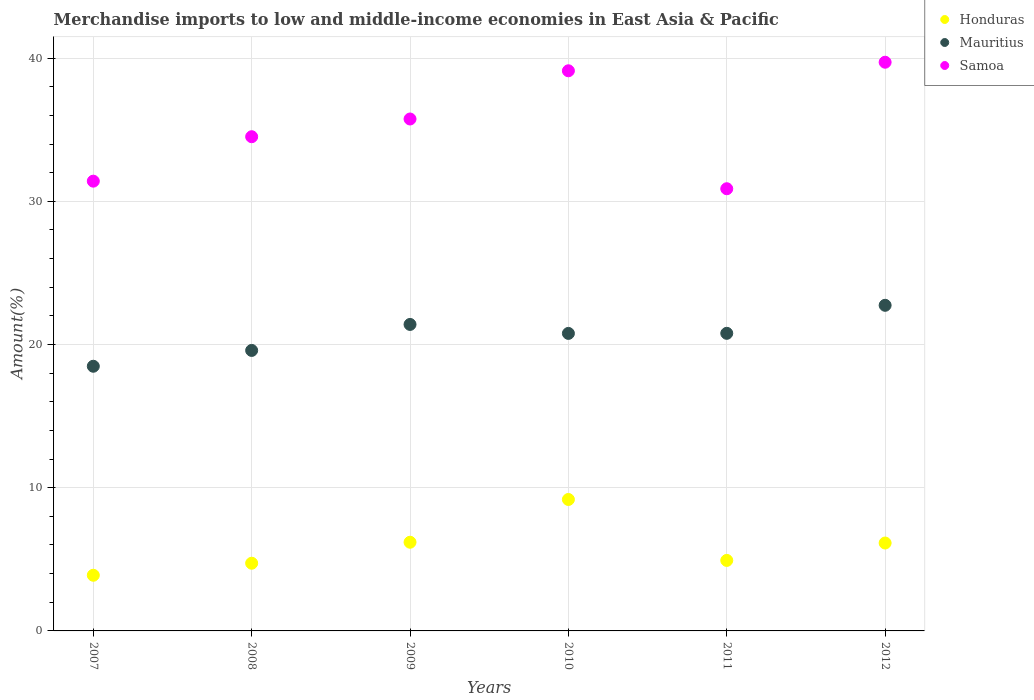How many different coloured dotlines are there?
Your answer should be very brief. 3. Is the number of dotlines equal to the number of legend labels?
Your answer should be very brief. Yes. What is the percentage of amount earned from merchandise imports in Samoa in 2008?
Keep it short and to the point. 34.51. Across all years, what is the maximum percentage of amount earned from merchandise imports in Mauritius?
Offer a terse response. 22.74. Across all years, what is the minimum percentage of amount earned from merchandise imports in Honduras?
Provide a succinct answer. 3.89. In which year was the percentage of amount earned from merchandise imports in Mauritius maximum?
Provide a short and direct response. 2012. In which year was the percentage of amount earned from merchandise imports in Samoa minimum?
Ensure brevity in your answer.  2011. What is the total percentage of amount earned from merchandise imports in Honduras in the graph?
Your response must be concise. 35.05. What is the difference between the percentage of amount earned from merchandise imports in Honduras in 2010 and that in 2012?
Give a very brief answer. 3.04. What is the difference between the percentage of amount earned from merchandise imports in Honduras in 2012 and the percentage of amount earned from merchandise imports in Mauritius in 2009?
Keep it short and to the point. -15.26. What is the average percentage of amount earned from merchandise imports in Honduras per year?
Your answer should be very brief. 5.84. In the year 2012, what is the difference between the percentage of amount earned from merchandise imports in Mauritius and percentage of amount earned from merchandise imports in Honduras?
Offer a terse response. 16.6. In how many years, is the percentage of amount earned from merchandise imports in Honduras greater than 14 %?
Offer a terse response. 0. What is the ratio of the percentage of amount earned from merchandise imports in Honduras in 2007 to that in 2010?
Your answer should be very brief. 0.42. What is the difference between the highest and the second highest percentage of amount earned from merchandise imports in Mauritius?
Offer a terse response. 1.34. What is the difference between the highest and the lowest percentage of amount earned from merchandise imports in Samoa?
Make the answer very short. 8.83. Is the sum of the percentage of amount earned from merchandise imports in Mauritius in 2007 and 2008 greater than the maximum percentage of amount earned from merchandise imports in Samoa across all years?
Keep it short and to the point. No. Is it the case that in every year, the sum of the percentage of amount earned from merchandise imports in Honduras and percentage of amount earned from merchandise imports in Samoa  is greater than the percentage of amount earned from merchandise imports in Mauritius?
Make the answer very short. Yes. Is the percentage of amount earned from merchandise imports in Samoa strictly greater than the percentage of amount earned from merchandise imports in Honduras over the years?
Offer a very short reply. Yes. Are the values on the major ticks of Y-axis written in scientific E-notation?
Keep it short and to the point. No. Does the graph contain any zero values?
Offer a terse response. No. Where does the legend appear in the graph?
Give a very brief answer. Top right. What is the title of the graph?
Ensure brevity in your answer.  Merchandise imports to low and middle-income economies in East Asia & Pacific. Does "Isle of Man" appear as one of the legend labels in the graph?
Offer a terse response. No. What is the label or title of the X-axis?
Make the answer very short. Years. What is the label or title of the Y-axis?
Offer a very short reply. Amount(%). What is the Amount(%) in Honduras in 2007?
Offer a terse response. 3.89. What is the Amount(%) of Mauritius in 2007?
Your answer should be very brief. 18.48. What is the Amount(%) in Samoa in 2007?
Ensure brevity in your answer.  31.41. What is the Amount(%) in Honduras in 2008?
Make the answer very short. 4.73. What is the Amount(%) in Mauritius in 2008?
Keep it short and to the point. 19.59. What is the Amount(%) of Samoa in 2008?
Your response must be concise. 34.51. What is the Amount(%) in Honduras in 2009?
Your response must be concise. 6.19. What is the Amount(%) of Mauritius in 2009?
Offer a very short reply. 21.4. What is the Amount(%) of Samoa in 2009?
Offer a very short reply. 35.75. What is the Amount(%) in Honduras in 2010?
Ensure brevity in your answer.  9.18. What is the Amount(%) in Mauritius in 2010?
Your response must be concise. 20.78. What is the Amount(%) in Samoa in 2010?
Your response must be concise. 39.11. What is the Amount(%) of Honduras in 2011?
Your answer should be compact. 4.92. What is the Amount(%) of Mauritius in 2011?
Keep it short and to the point. 20.78. What is the Amount(%) of Samoa in 2011?
Offer a very short reply. 30.88. What is the Amount(%) of Honduras in 2012?
Offer a terse response. 6.14. What is the Amount(%) in Mauritius in 2012?
Make the answer very short. 22.74. What is the Amount(%) of Samoa in 2012?
Your answer should be compact. 39.71. Across all years, what is the maximum Amount(%) in Honduras?
Offer a terse response. 9.18. Across all years, what is the maximum Amount(%) in Mauritius?
Keep it short and to the point. 22.74. Across all years, what is the maximum Amount(%) in Samoa?
Your response must be concise. 39.71. Across all years, what is the minimum Amount(%) of Honduras?
Your answer should be compact. 3.89. Across all years, what is the minimum Amount(%) in Mauritius?
Provide a succinct answer. 18.48. Across all years, what is the minimum Amount(%) in Samoa?
Your response must be concise. 30.88. What is the total Amount(%) in Honduras in the graph?
Offer a very short reply. 35.05. What is the total Amount(%) in Mauritius in the graph?
Your answer should be compact. 123.77. What is the total Amount(%) in Samoa in the graph?
Make the answer very short. 211.37. What is the difference between the Amount(%) of Honduras in 2007 and that in 2008?
Offer a terse response. -0.84. What is the difference between the Amount(%) of Mauritius in 2007 and that in 2008?
Provide a succinct answer. -1.1. What is the difference between the Amount(%) of Samoa in 2007 and that in 2008?
Make the answer very short. -3.1. What is the difference between the Amount(%) in Honduras in 2007 and that in 2009?
Your answer should be compact. -2.31. What is the difference between the Amount(%) in Mauritius in 2007 and that in 2009?
Provide a succinct answer. -2.92. What is the difference between the Amount(%) in Samoa in 2007 and that in 2009?
Make the answer very short. -4.34. What is the difference between the Amount(%) of Honduras in 2007 and that in 2010?
Provide a short and direct response. -5.29. What is the difference between the Amount(%) of Mauritius in 2007 and that in 2010?
Keep it short and to the point. -2.29. What is the difference between the Amount(%) of Samoa in 2007 and that in 2010?
Provide a short and direct response. -7.71. What is the difference between the Amount(%) in Honduras in 2007 and that in 2011?
Offer a terse response. -1.04. What is the difference between the Amount(%) of Mauritius in 2007 and that in 2011?
Give a very brief answer. -2.3. What is the difference between the Amount(%) in Samoa in 2007 and that in 2011?
Provide a succinct answer. 0.53. What is the difference between the Amount(%) in Honduras in 2007 and that in 2012?
Ensure brevity in your answer.  -2.25. What is the difference between the Amount(%) of Mauritius in 2007 and that in 2012?
Provide a succinct answer. -4.26. What is the difference between the Amount(%) in Samoa in 2007 and that in 2012?
Provide a succinct answer. -8.31. What is the difference between the Amount(%) in Honduras in 2008 and that in 2009?
Your answer should be compact. -1.47. What is the difference between the Amount(%) of Mauritius in 2008 and that in 2009?
Your answer should be very brief. -1.82. What is the difference between the Amount(%) of Samoa in 2008 and that in 2009?
Offer a terse response. -1.24. What is the difference between the Amount(%) of Honduras in 2008 and that in 2010?
Your answer should be very brief. -4.45. What is the difference between the Amount(%) of Mauritius in 2008 and that in 2010?
Your answer should be very brief. -1.19. What is the difference between the Amount(%) in Samoa in 2008 and that in 2010?
Your answer should be very brief. -4.6. What is the difference between the Amount(%) of Honduras in 2008 and that in 2011?
Your answer should be very brief. -0.2. What is the difference between the Amount(%) of Mauritius in 2008 and that in 2011?
Make the answer very short. -1.2. What is the difference between the Amount(%) of Samoa in 2008 and that in 2011?
Your response must be concise. 3.63. What is the difference between the Amount(%) of Honduras in 2008 and that in 2012?
Your answer should be very brief. -1.41. What is the difference between the Amount(%) of Mauritius in 2008 and that in 2012?
Your answer should be very brief. -3.15. What is the difference between the Amount(%) of Samoa in 2008 and that in 2012?
Provide a short and direct response. -5.2. What is the difference between the Amount(%) of Honduras in 2009 and that in 2010?
Give a very brief answer. -2.99. What is the difference between the Amount(%) in Mauritius in 2009 and that in 2010?
Provide a succinct answer. 0.63. What is the difference between the Amount(%) in Samoa in 2009 and that in 2010?
Provide a short and direct response. -3.37. What is the difference between the Amount(%) of Honduras in 2009 and that in 2011?
Make the answer very short. 1.27. What is the difference between the Amount(%) in Mauritius in 2009 and that in 2011?
Your response must be concise. 0.62. What is the difference between the Amount(%) in Samoa in 2009 and that in 2011?
Ensure brevity in your answer.  4.87. What is the difference between the Amount(%) of Honduras in 2009 and that in 2012?
Provide a succinct answer. 0.05. What is the difference between the Amount(%) of Mauritius in 2009 and that in 2012?
Your answer should be very brief. -1.34. What is the difference between the Amount(%) in Samoa in 2009 and that in 2012?
Keep it short and to the point. -3.96. What is the difference between the Amount(%) of Honduras in 2010 and that in 2011?
Keep it short and to the point. 4.26. What is the difference between the Amount(%) of Mauritius in 2010 and that in 2011?
Your answer should be compact. -0.01. What is the difference between the Amount(%) of Samoa in 2010 and that in 2011?
Offer a very short reply. 8.24. What is the difference between the Amount(%) of Honduras in 2010 and that in 2012?
Provide a short and direct response. 3.04. What is the difference between the Amount(%) of Mauritius in 2010 and that in 2012?
Offer a terse response. -1.96. What is the difference between the Amount(%) in Samoa in 2010 and that in 2012?
Offer a very short reply. -0.6. What is the difference between the Amount(%) of Honduras in 2011 and that in 2012?
Offer a very short reply. -1.21. What is the difference between the Amount(%) of Mauritius in 2011 and that in 2012?
Offer a terse response. -1.96. What is the difference between the Amount(%) of Samoa in 2011 and that in 2012?
Make the answer very short. -8.83. What is the difference between the Amount(%) in Honduras in 2007 and the Amount(%) in Mauritius in 2008?
Your response must be concise. -15.7. What is the difference between the Amount(%) in Honduras in 2007 and the Amount(%) in Samoa in 2008?
Offer a very short reply. -30.62. What is the difference between the Amount(%) in Mauritius in 2007 and the Amount(%) in Samoa in 2008?
Your answer should be very brief. -16.03. What is the difference between the Amount(%) in Honduras in 2007 and the Amount(%) in Mauritius in 2009?
Ensure brevity in your answer.  -17.52. What is the difference between the Amount(%) in Honduras in 2007 and the Amount(%) in Samoa in 2009?
Keep it short and to the point. -31.86. What is the difference between the Amount(%) of Mauritius in 2007 and the Amount(%) of Samoa in 2009?
Your answer should be compact. -17.27. What is the difference between the Amount(%) in Honduras in 2007 and the Amount(%) in Mauritius in 2010?
Offer a terse response. -16.89. What is the difference between the Amount(%) of Honduras in 2007 and the Amount(%) of Samoa in 2010?
Your response must be concise. -35.23. What is the difference between the Amount(%) of Mauritius in 2007 and the Amount(%) of Samoa in 2010?
Make the answer very short. -20.63. What is the difference between the Amount(%) in Honduras in 2007 and the Amount(%) in Mauritius in 2011?
Provide a succinct answer. -16.89. What is the difference between the Amount(%) of Honduras in 2007 and the Amount(%) of Samoa in 2011?
Provide a succinct answer. -26.99. What is the difference between the Amount(%) in Mauritius in 2007 and the Amount(%) in Samoa in 2011?
Ensure brevity in your answer.  -12.4. What is the difference between the Amount(%) of Honduras in 2007 and the Amount(%) of Mauritius in 2012?
Your response must be concise. -18.85. What is the difference between the Amount(%) in Honduras in 2007 and the Amount(%) in Samoa in 2012?
Your answer should be compact. -35.83. What is the difference between the Amount(%) in Mauritius in 2007 and the Amount(%) in Samoa in 2012?
Your answer should be compact. -21.23. What is the difference between the Amount(%) in Honduras in 2008 and the Amount(%) in Mauritius in 2009?
Provide a succinct answer. -16.67. What is the difference between the Amount(%) of Honduras in 2008 and the Amount(%) of Samoa in 2009?
Your response must be concise. -31.02. What is the difference between the Amount(%) of Mauritius in 2008 and the Amount(%) of Samoa in 2009?
Your answer should be compact. -16.16. What is the difference between the Amount(%) of Honduras in 2008 and the Amount(%) of Mauritius in 2010?
Provide a short and direct response. -16.05. What is the difference between the Amount(%) of Honduras in 2008 and the Amount(%) of Samoa in 2010?
Your response must be concise. -34.39. What is the difference between the Amount(%) in Mauritius in 2008 and the Amount(%) in Samoa in 2010?
Offer a very short reply. -19.53. What is the difference between the Amount(%) of Honduras in 2008 and the Amount(%) of Mauritius in 2011?
Your answer should be compact. -16.05. What is the difference between the Amount(%) in Honduras in 2008 and the Amount(%) in Samoa in 2011?
Keep it short and to the point. -26.15. What is the difference between the Amount(%) of Mauritius in 2008 and the Amount(%) of Samoa in 2011?
Provide a short and direct response. -11.29. What is the difference between the Amount(%) in Honduras in 2008 and the Amount(%) in Mauritius in 2012?
Your answer should be compact. -18.01. What is the difference between the Amount(%) of Honduras in 2008 and the Amount(%) of Samoa in 2012?
Make the answer very short. -34.99. What is the difference between the Amount(%) of Mauritius in 2008 and the Amount(%) of Samoa in 2012?
Your answer should be compact. -20.13. What is the difference between the Amount(%) in Honduras in 2009 and the Amount(%) in Mauritius in 2010?
Offer a very short reply. -14.58. What is the difference between the Amount(%) in Honduras in 2009 and the Amount(%) in Samoa in 2010?
Give a very brief answer. -32.92. What is the difference between the Amount(%) in Mauritius in 2009 and the Amount(%) in Samoa in 2010?
Offer a terse response. -17.71. What is the difference between the Amount(%) in Honduras in 2009 and the Amount(%) in Mauritius in 2011?
Provide a short and direct response. -14.59. What is the difference between the Amount(%) of Honduras in 2009 and the Amount(%) of Samoa in 2011?
Keep it short and to the point. -24.69. What is the difference between the Amount(%) of Mauritius in 2009 and the Amount(%) of Samoa in 2011?
Provide a succinct answer. -9.48. What is the difference between the Amount(%) in Honduras in 2009 and the Amount(%) in Mauritius in 2012?
Your answer should be compact. -16.55. What is the difference between the Amount(%) of Honduras in 2009 and the Amount(%) of Samoa in 2012?
Your answer should be compact. -33.52. What is the difference between the Amount(%) of Mauritius in 2009 and the Amount(%) of Samoa in 2012?
Offer a very short reply. -18.31. What is the difference between the Amount(%) of Honduras in 2010 and the Amount(%) of Mauritius in 2011?
Provide a short and direct response. -11.6. What is the difference between the Amount(%) in Honduras in 2010 and the Amount(%) in Samoa in 2011?
Offer a terse response. -21.7. What is the difference between the Amount(%) of Mauritius in 2010 and the Amount(%) of Samoa in 2011?
Your response must be concise. -10.1. What is the difference between the Amount(%) in Honduras in 2010 and the Amount(%) in Mauritius in 2012?
Ensure brevity in your answer.  -13.56. What is the difference between the Amount(%) of Honduras in 2010 and the Amount(%) of Samoa in 2012?
Your answer should be compact. -30.53. What is the difference between the Amount(%) of Mauritius in 2010 and the Amount(%) of Samoa in 2012?
Offer a very short reply. -18.94. What is the difference between the Amount(%) of Honduras in 2011 and the Amount(%) of Mauritius in 2012?
Your response must be concise. -17.81. What is the difference between the Amount(%) in Honduras in 2011 and the Amount(%) in Samoa in 2012?
Offer a very short reply. -34.79. What is the difference between the Amount(%) in Mauritius in 2011 and the Amount(%) in Samoa in 2012?
Ensure brevity in your answer.  -18.93. What is the average Amount(%) in Honduras per year?
Provide a short and direct response. 5.84. What is the average Amount(%) in Mauritius per year?
Ensure brevity in your answer.  20.63. What is the average Amount(%) of Samoa per year?
Your answer should be very brief. 35.23. In the year 2007, what is the difference between the Amount(%) in Honduras and Amount(%) in Mauritius?
Offer a very short reply. -14.6. In the year 2007, what is the difference between the Amount(%) of Honduras and Amount(%) of Samoa?
Offer a terse response. -27.52. In the year 2007, what is the difference between the Amount(%) of Mauritius and Amount(%) of Samoa?
Your answer should be very brief. -12.93. In the year 2008, what is the difference between the Amount(%) of Honduras and Amount(%) of Mauritius?
Your answer should be very brief. -14.86. In the year 2008, what is the difference between the Amount(%) of Honduras and Amount(%) of Samoa?
Your answer should be very brief. -29.78. In the year 2008, what is the difference between the Amount(%) of Mauritius and Amount(%) of Samoa?
Provide a short and direct response. -14.92. In the year 2009, what is the difference between the Amount(%) of Honduras and Amount(%) of Mauritius?
Provide a short and direct response. -15.21. In the year 2009, what is the difference between the Amount(%) of Honduras and Amount(%) of Samoa?
Provide a short and direct response. -29.56. In the year 2009, what is the difference between the Amount(%) of Mauritius and Amount(%) of Samoa?
Give a very brief answer. -14.35. In the year 2010, what is the difference between the Amount(%) of Honduras and Amount(%) of Mauritius?
Make the answer very short. -11.6. In the year 2010, what is the difference between the Amount(%) of Honduras and Amount(%) of Samoa?
Ensure brevity in your answer.  -29.94. In the year 2010, what is the difference between the Amount(%) of Mauritius and Amount(%) of Samoa?
Your response must be concise. -18.34. In the year 2011, what is the difference between the Amount(%) in Honduras and Amount(%) in Mauritius?
Make the answer very short. -15.86. In the year 2011, what is the difference between the Amount(%) of Honduras and Amount(%) of Samoa?
Offer a terse response. -25.95. In the year 2011, what is the difference between the Amount(%) of Mauritius and Amount(%) of Samoa?
Your answer should be compact. -10.1. In the year 2012, what is the difference between the Amount(%) in Honduras and Amount(%) in Mauritius?
Provide a succinct answer. -16.6. In the year 2012, what is the difference between the Amount(%) in Honduras and Amount(%) in Samoa?
Keep it short and to the point. -33.57. In the year 2012, what is the difference between the Amount(%) in Mauritius and Amount(%) in Samoa?
Provide a succinct answer. -16.97. What is the ratio of the Amount(%) of Honduras in 2007 to that in 2008?
Ensure brevity in your answer.  0.82. What is the ratio of the Amount(%) in Mauritius in 2007 to that in 2008?
Ensure brevity in your answer.  0.94. What is the ratio of the Amount(%) in Samoa in 2007 to that in 2008?
Keep it short and to the point. 0.91. What is the ratio of the Amount(%) of Honduras in 2007 to that in 2009?
Your response must be concise. 0.63. What is the ratio of the Amount(%) in Mauritius in 2007 to that in 2009?
Your answer should be compact. 0.86. What is the ratio of the Amount(%) in Samoa in 2007 to that in 2009?
Your response must be concise. 0.88. What is the ratio of the Amount(%) of Honduras in 2007 to that in 2010?
Provide a succinct answer. 0.42. What is the ratio of the Amount(%) of Mauritius in 2007 to that in 2010?
Offer a very short reply. 0.89. What is the ratio of the Amount(%) of Samoa in 2007 to that in 2010?
Provide a succinct answer. 0.8. What is the ratio of the Amount(%) of Honduras in 2007 to that in 2011?
Offer a very short reply. 0.79. What is the ratio of the Amount(%) in Mauritius in 2007 to that in 2011?
Provide a succinct answer. 0.89. What is the ratio of the Amount(%) of Samoa in 2007 to that in 2011?
Provide a short and direct response. 1.02. What is the ratio of the Amount(%) of Honduras in 2007 to that in 2012?
Provide a short and direct response. 0.63. What is the ratio of the Amount(%) of Mauritius in 2007 to that in 2012?
Your response must be concise. 0.81. What is the ratio of the Amount(%) in Samoa in 2007 to that in 2012?
Make the answer very short. 0.79. What is the ratio of the Amount(%) in Honduras in 2008 to that in 2009?
Provide a succinct answer. 0.76. What is the ratio of the Amount(%) of Mauritius in 2008 to that in 2009?
Your answer should be very brief. 0.92. What is the ratio of the Amount(%) of Samoa in 2008 to that in 2009?
Your answer should be compact. 0.97. What is the ratio of the Amount(%) in Honduras in 2008 to that in 2010?
Ensure brevity in your answer.  0.52. What is the ratio of the Amount(%) of Mauritius in 2008 to that in 2010?
Your answer should be compact. 0.94. What is the ratio of the Amount(%) of Samoa in 2008 to that in 2010?
Give a very brief answer. 0.88. What is the ratio of the Amount(%) in Honduras in 2008 to that in 2011?
Offer a terse response. 0.96. What is the ratio of the Amount(%) of Mauritius in 2008 to that in 2011?
Your answer should be very brief. 0.94. What is the ratio of the Amount(%) of Samoa in 2008 to that in 2011?
Make the answer very short. 1.12. What is the ratio of the Amount(%) of Honduras in 2008 to that in 2012?
Offer a terse response. 0.77. What is the ratio of the Amount(%) in Mauritius in 2008 to that in 2012?
Make the answer very short. 0.86. What is the ratio of the Amount(%) of Samoa in 2008 to that in 2012?
Your answer should be compact. 0.87. What is the ratio of the Amount(%) in Honduras in 2009 to that in 2010?
Make the answer very short. 0.67. What is the ratio of the Amount(%) of Mauritius in 2009 to that in 2010?
Give a very brief answer. 1.03. What is the ratio of the Amount(%) of Samoa in 2009 to that in 2010?
Offer a very short reply. 0.91. What is the ratio of the Amount(%) of Honduras in 2009 to that in 2011?
Offer a very short reply. 1.26. What is the ratio of the Amount(%) in Mauritius in 2009 to that in 2011?
Ensure brevity in your answer.  1.03. What is the ratio of the Amount(%) in Samoa in 2009 to that in 2011?
Offer a terse response. 1.16. What is the ratio of the Amount(%) of Honduras in 2009 to that in 2012?
Give a very brief answer. 1.01. What is the ratio of the Amount(%) in Samoa in 2009 to that in 2012?
Provide a succinct answer. 0.9. What is the ratio of the Amount(%) of Honduras in 2010 to that in 2011?
Provide a short and direct response. 1.86. What is the ratio of the Amount(%) in Samoa in 2010 to that in 2011?
Keep it short and to the point. 1.27. What is the ratio of the Amount(%) of Honduras in 2010 to that in 2012?
Make the answer very short. 1.5. What is the ratio of the Amount(%) of Mauritius in 2010 to that in 2012?
Provide a short and direct response. 0.91. What is the ratio of the Amount(%) in Samoa in 2010 to that in 2012?
Provide a succinct answer. 0.98. What is the ratio of the Amount(%) in Honduras in 2011 to that in 2012?
Your answer should be compact. 0.8. What is the ratio of the Amount(%) in Mauritius in 2011 to that in 2012?
Offer a terse response. 0.91. What is the ratio of the Amount(%) of Samoa in 2011 to that in 2012?
Ensure brevity in your answer.  0.78. What is the difference between the highest and the second highest Amount(%) in Honduras?
Provide a succinct answer. 2.99. What is the difference between the highest and the second highest Amount(%) of Mauritius?
Make the answer very short. 1.34. What is the difference between the highest and the second highest Amount(%) in Samoa?
Keep it short and to the point. 0.6. What is the difference between the highest and the lowest Amount(%) in Honduras?
Offer a very short reply. 5.29. What is the difference between the highest and the lowest Amount(%) in Mauritius?
Your answer should be very brief. 4.26. What is the difference between the highest and the lowest Amount(%) in Samoa?
Provide a short and direct response. 8.83. 